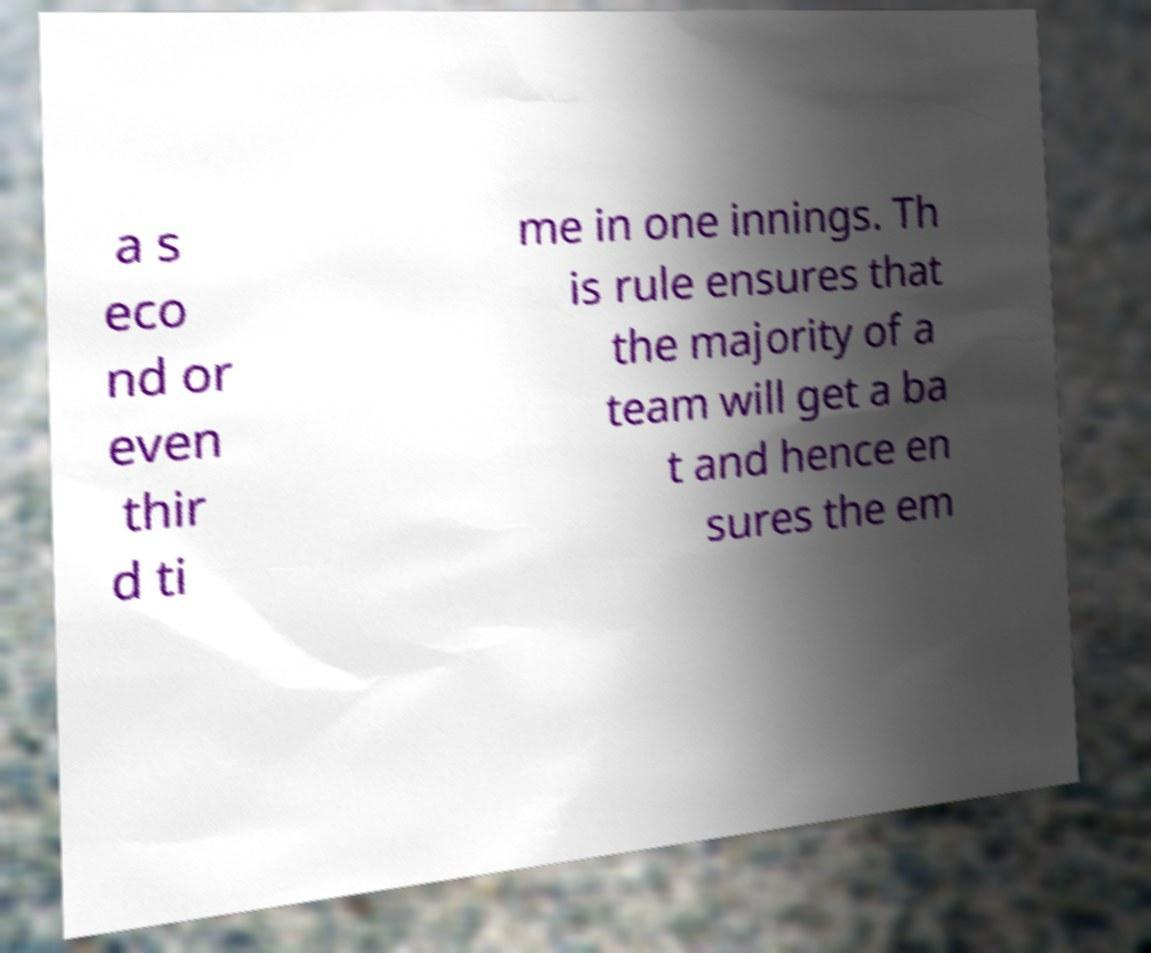Could you assist in decoding the text presented in this image and type it out clearly? a s eco nd or even thir d ti me in one innings. Th is rule ensures that the majority of a team will get a ba t and hence en sures the em 